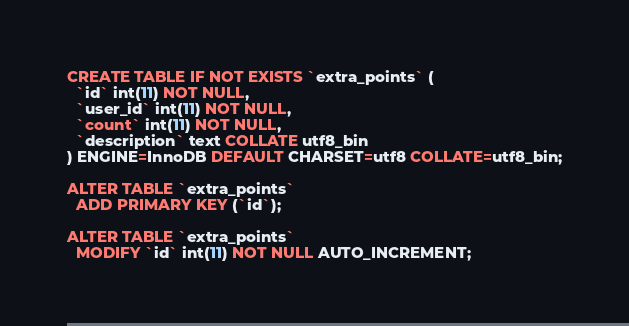<code> <loc_0><loc_0><loc_500><loc_500><_SQL_>CREATE TABLE IF NOT EXISTS `extra_points` (
  `id` int(11) NOT NULL,
  `user_id` int(11) NOT NULL,
  `count` int(11) NOT NULL,
  `description` text COLLATE utf8_bin
) ENGINE=InnoDB DEFAULT CHARSET=utf8 COLLATE=utf8_bin;

ALTER TABLE `extra_points`
  ADD PRIMARY KEY (`id`);

ALTER TABLE `extra_points`
  MODIFY `id` int(11) NOT NULL AUTO_INCREMENT;</code> 